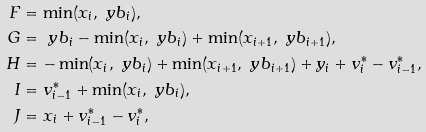<formula> <loc_0><loc_0><loc_500><loc_500>F & = \min ( x _ { i } , \ y b _ { i } ) , \\ G & = \ y b _ { i } - \min ( x _ { i } , \ y b _ { i } ) + \min ( x _ { i + 1 } , \ y b _ { i + 1 } ) , \\ H & = - \min ( x _ { i } , \ y b _ { i } ) + \min ( x _ { i + 1 } , \ y b _ { i + 1 } ) + y _ { i } + v _ { i } ^ { * } - v _ { i - 1 } ^ { * } , \\ I & = v _ { i - 1 } ^ { * } + \min ( x _ { i } , \ y b _ { i } ) , \\ J & = x _ { i } + v _ { i - 1 } ^ { * } - v _ { i } ^ { * } ,</formula> 